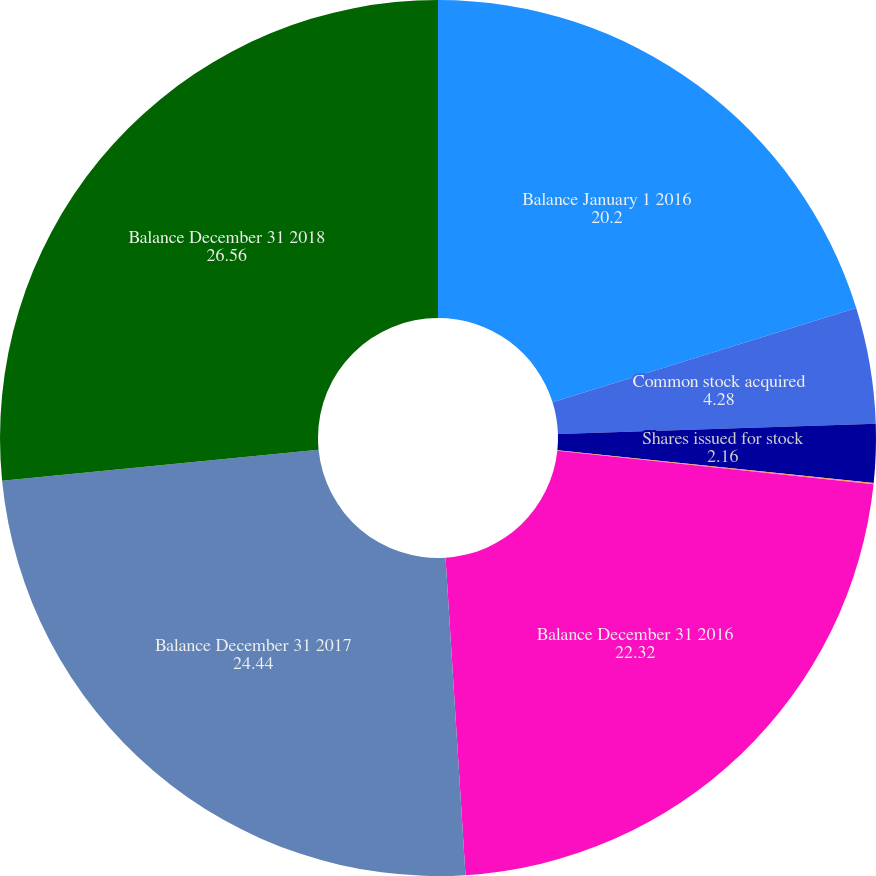<chart> <loc_0><loc_0><loc_500><loc_500><pie_chart><fcel>Balance January 1 2016<fcel>Common stock acquired<fcel>Shares issued for stock<fcel>Shares issued for restricted<fcel>Balance December 31 2016<fcel>Balance December 31 2017<fcel>Balance December 31 2018<nl><fcel>20.2%<fcel>4.28%<fcel>2.16%<fcel>0.04%<fcel>22.32%<fcel>24.44%<fcel>26.56%<nl></chart> 